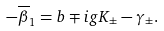Convert formula to latex. <formula><loc_0><loc_0><loc_500><loc_500>- \overline { \beta } _ { 1 } = b \mp i g K _ { \pm } - \gamma _ { \pm } .</formula> 